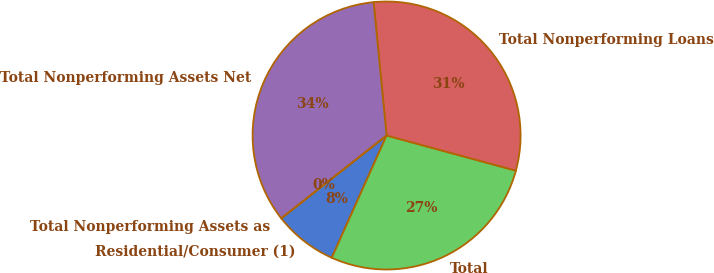Convert chart. <chart><loc_0><loc_0><loc_500><loc_500><pie_chart><fcel>Residential/Consumer (1)<fcel>Total<fcel>Total Nonperforming Loans<fcel>Total Nonperforming Assets Net<fcel>Total Nonperforming Assets as<nl><fcel>7.69%<fcel>27.48%<fcel>30.77%<fcel>34.06%<fcel>0.0%<nl></chart> 